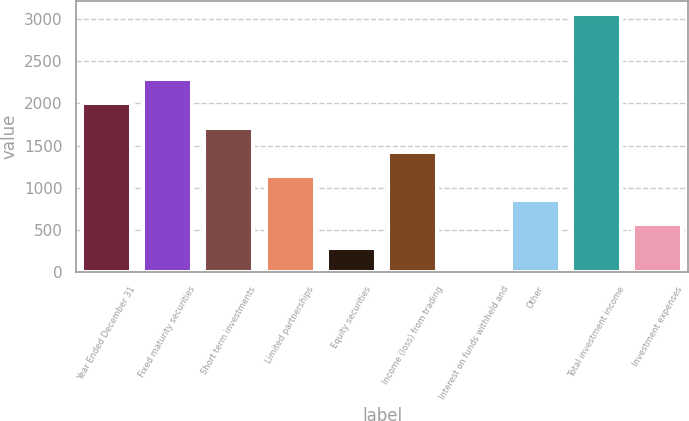Convert chart. <chart><loc_0><loc_0><loc_500><loc_500><bar_chart><fcel>Year Ended December 31<fcel>Fixed maturity securities<fcel>Short term investments<fcel>Limited partnerships<fcel>Equity securities<fcel>Income (loss) from trading<fcel>Interest on funds withheld and<fcel>Other<fcel>Total investment income<fcel>Investment expenses<nl><fcel>2007<fcel>2290.7<fcel>1703.2<fcel>1135.8<fcel>284.7<fcel>1419.5<fcel>1<fcel>852.1<fcel>3068.7<fcel>568.4<nl></chart> 